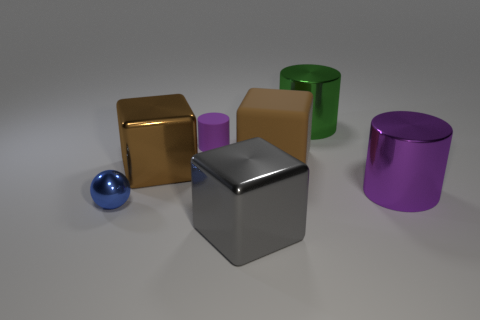Subtract all purple matte cylinders. How many cylinders are left? 2 Add 1 tiny purple rubber objects. How many objects exist? 8 Subtract 1 blocks. How many blocks are left? 2 Subtract all brown blocks. How many blocks are left? 1 Subtract all cylinders. How many objects are left? 4 Subtract all brown cubes. Subtract all red cylinders. How many cubes are left? 1 Subtract all red blocks. How many purple cylinders are left? 2 Subtract all large red balls. Subtract all large metal cylinders. How many objects are left? 5 Add 4 large brown matte cubes. How many large brown matte cubes are left? 5 Add 5 red metallic cylinders. How many red metallic cylinders exist? 5 